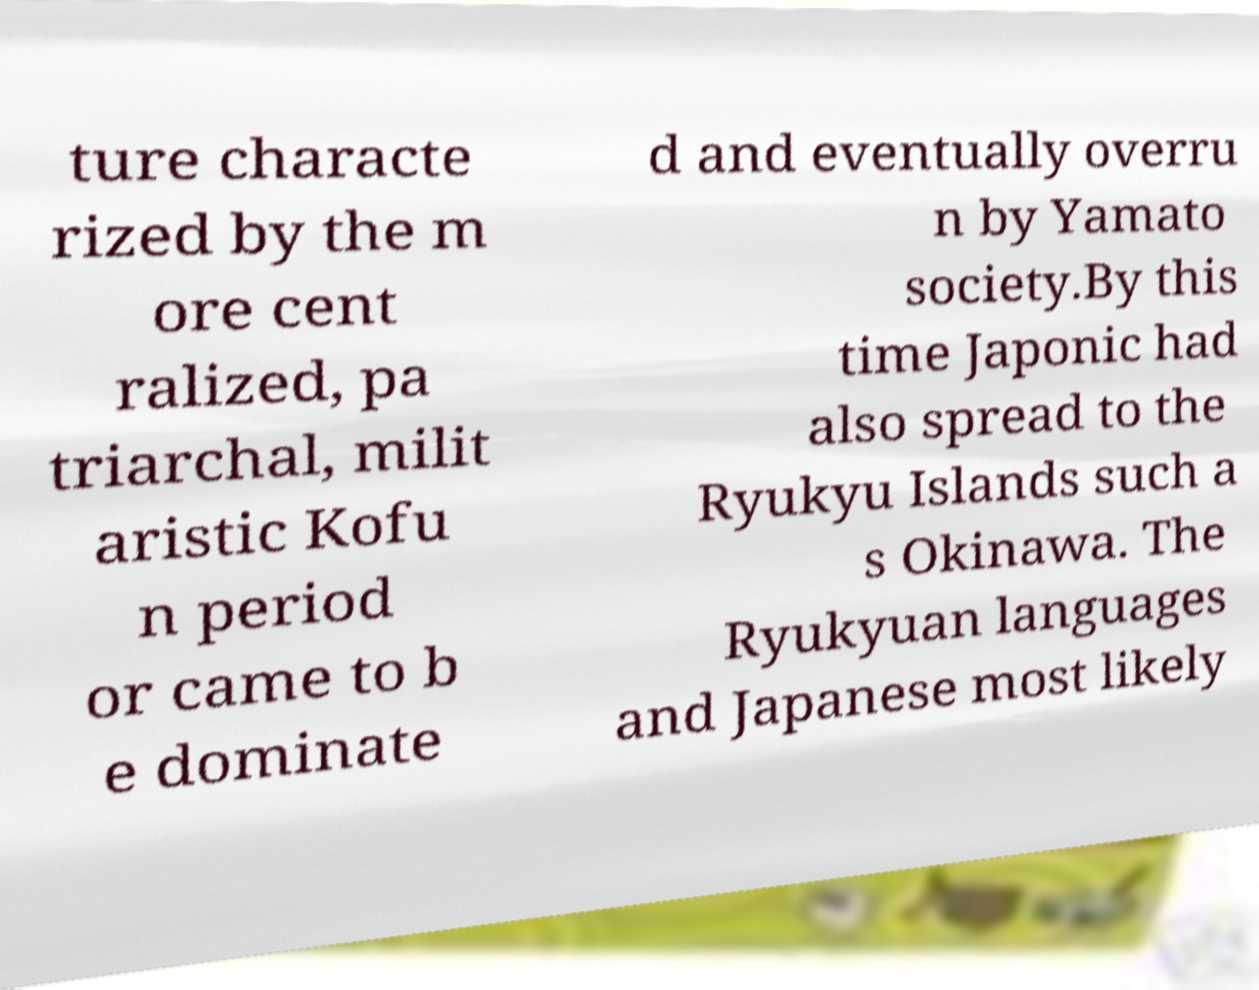Please identify and transcribe the text found in this image. ture characte rized by the m ore cent ralized, pa triarchal, milit aristic Kofu n period or came to b e dominate d and eventually overru n by Yamato society.By this time Japonic had also spread to the Ryukyu Islands such a s Okinawa. The Ryukyuan languages and Japanese most likely 